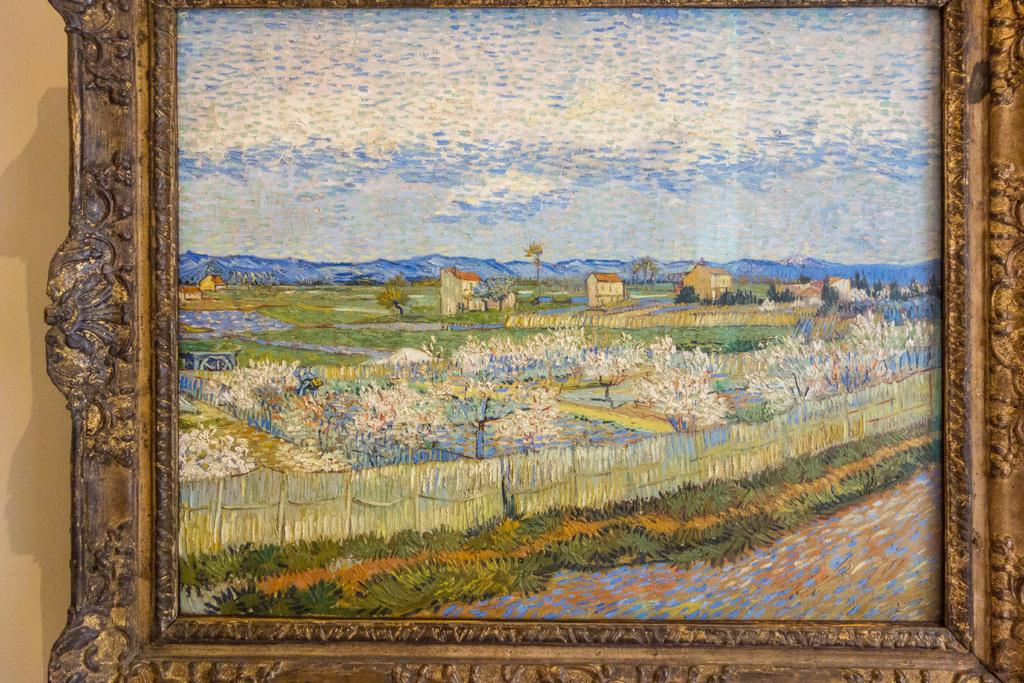What is depicted on the wall in the image? There is a wall painting in the image. Where is the wall painting located? The wall painting is placed on a wall. What type of basket is hanging from the wall painting in the image? There is no basket present in the image. 